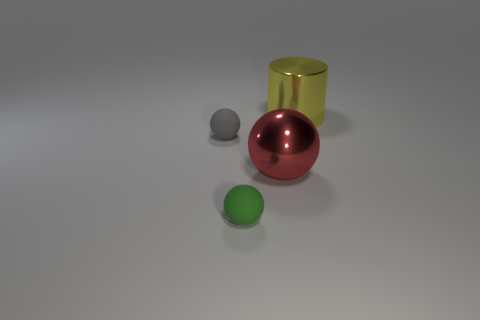There is a rubber thing behind the matte ball that is in front of the large red shiny object; what shape is it?
Your response must be concise. Sphere. Is there a large metal object that is in front of the matte object behind the large object that is in front of the large yellow thing?
Provide a short and direct response. Yes. Is the color of the tiny rubber object to the right of the gray thing the same as the small thing behind the red sphere?
Ensure brevity in your answer.  No. What is the material of the thing that is the same size as the metal sphere?
Give a very brief answer. Metal. There is a metallic thing on the right side of the large thing that is on the left side of the metal thing behind the gray matte object; what is its size?
Provide a short and direct response. Large. How many other things are made of the same material as the tiny gray sphere?
Your response must be concise. 1. There is a thing that is in front of the large ball; what is its size?
Provide a short and direct response. Small. How many objects are both on the left side of the red metal thing and in front of the small gray rubber object?
Provide a short and direct response. 1. What material is the small ball in front of the big object that is in front of the gray sphere made of?
Provide a short and direct response. Rubber. There is a gray thing that is the same shape as the large red thing; what is it made of?
Ensure brevity in your answer.  Rubber. 